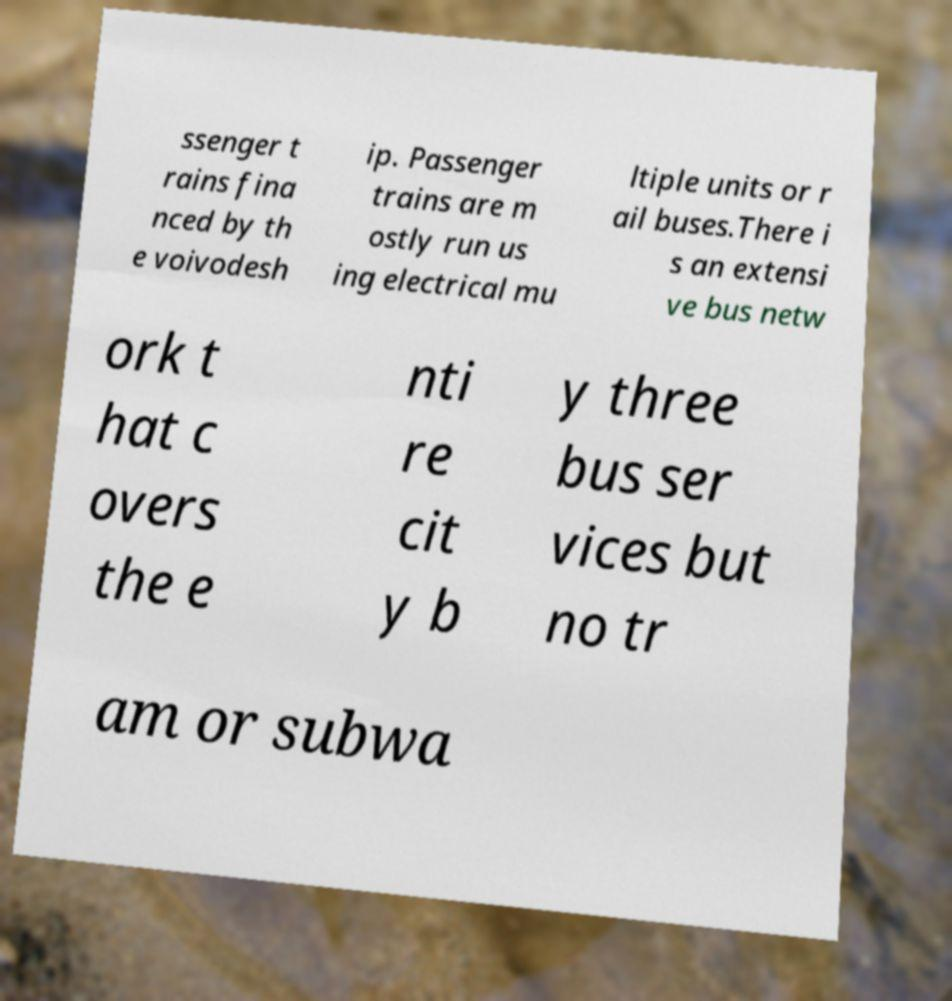What messages or text are displayed in this image? I need them in a readable, typed format. ssenger t rains fina nced by th e voivodesh ip. Passenger trains are m ostly run us ing electrical mu ltiple units or r ail buses.There i s an extensi ve bus netw ork t hat c overs the e nti re cit y b y three bus ser vices but no tr am or subwa 